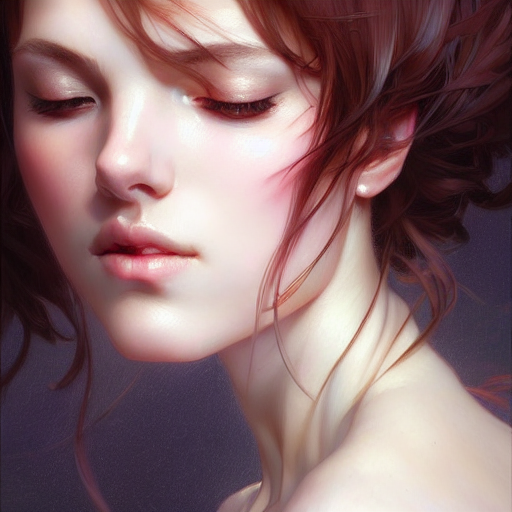Is the quality of this image excellent? The image is of high quality, with remarkable detail, vivid color, and sharp focus that contribute to its striking clarity and lifelike appearance. 